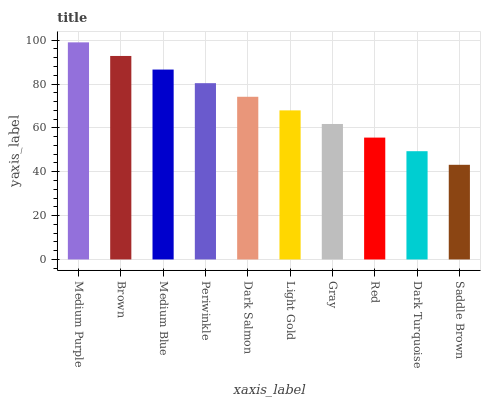Is Saddle Brown the minimum?
Answer yes or no. Yes. Is Medium Purple the maximum?
Answer yes or no. Yes. Is Brown the minimum?
Answer yes or no. No. Is Brown the maximum?
Answer yes or no. No. Is Medium Purple greater than Brown?
Answer yes or no. Yes. Is Brown less than Medium Purple?
Answer yes or no. Yes. Is Brown greater than Medium Purple?
Answer yes or no. No. Is Medium Purple less than Brown?
Answer yes or no. No. Is Dark Salmon the high median?
Answer yes or no. Yes. Is Light Gold the low median?
Answer yes or no. Yes. Is Red the high median?
Answer yes or no. No. Is Red the low median?
Answer yes or no. No. 